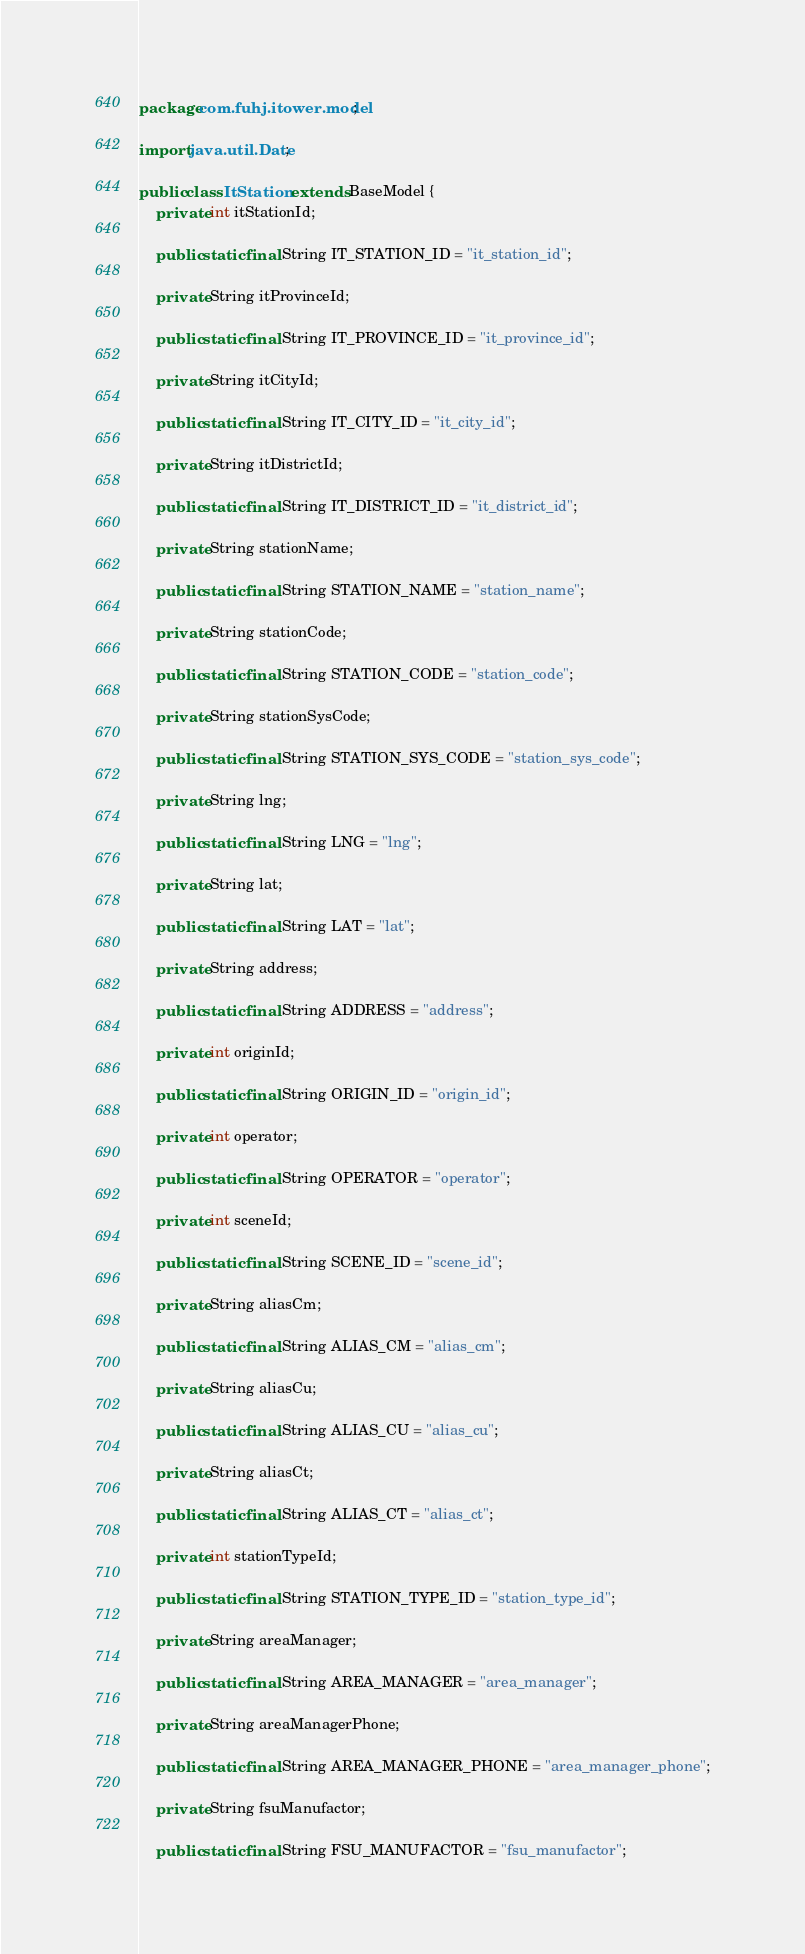<code> <loc_0><loc_0><loc_500><loc_500><_Java_>package com.fuhj.itower.model;

import java.util.Date;

public class ItStation extends BaseModel {
    private int itStationId;

    public static final String IT_STATION_ID = "it_station_id";

    private String itProvinceId;

    public static final String IT_PROVINCE_ID = "it_province_id";

    private String itCityId;

    public static final String IT_CITY_ID = "it_city_id";

    private String itDistrictId;

    public static final String IT_DISTRICT_ID = "it_district_id";

    private String stationName;

    public static final String STATION_NAME = "station_name";

    private String stationCode;

    public static final String STATION_CODE = "station_code";

    private String stationSysCode;

    public static final String STATION_SYS_CODE = "station_sys_code";

    private String lng;

    public static final String LNG = "lng";

    private String lat;

    public static final String LAT = "lat";

    private String address;

    public static final String ADDRESS = "address";

    private int originId;

    public static final String ORIGIN_ID = "origin_id";

    private int operator;

    public static final String OPERATOR = "operator";

    private int sceneId;

    public static final String SCENE_ID = "scene_id";

    private String aliasCm;

    public static final String ALIAS_CM = "alias_cm";

    private String aliasCu;

    public static final String ALIAS_CU = "alias_cu";

    private String aliasCt;

    public static final String ALIAS_CT = "alias_ct";

    private int stationTypeId;

    public static final String STATION_TYPE_ID = "station_type_id";

    private String areaManager;

    public static final String AREA_MANAGER = "area_manager";

    private String areaManagerPhone;

    public static final String AREA_MANAGER_PHONE = "area_manager_phone";

    private String fsuManufactor;

    public static final String FSU_MANUFACTOR = "fsu_manufactor";
</code> 